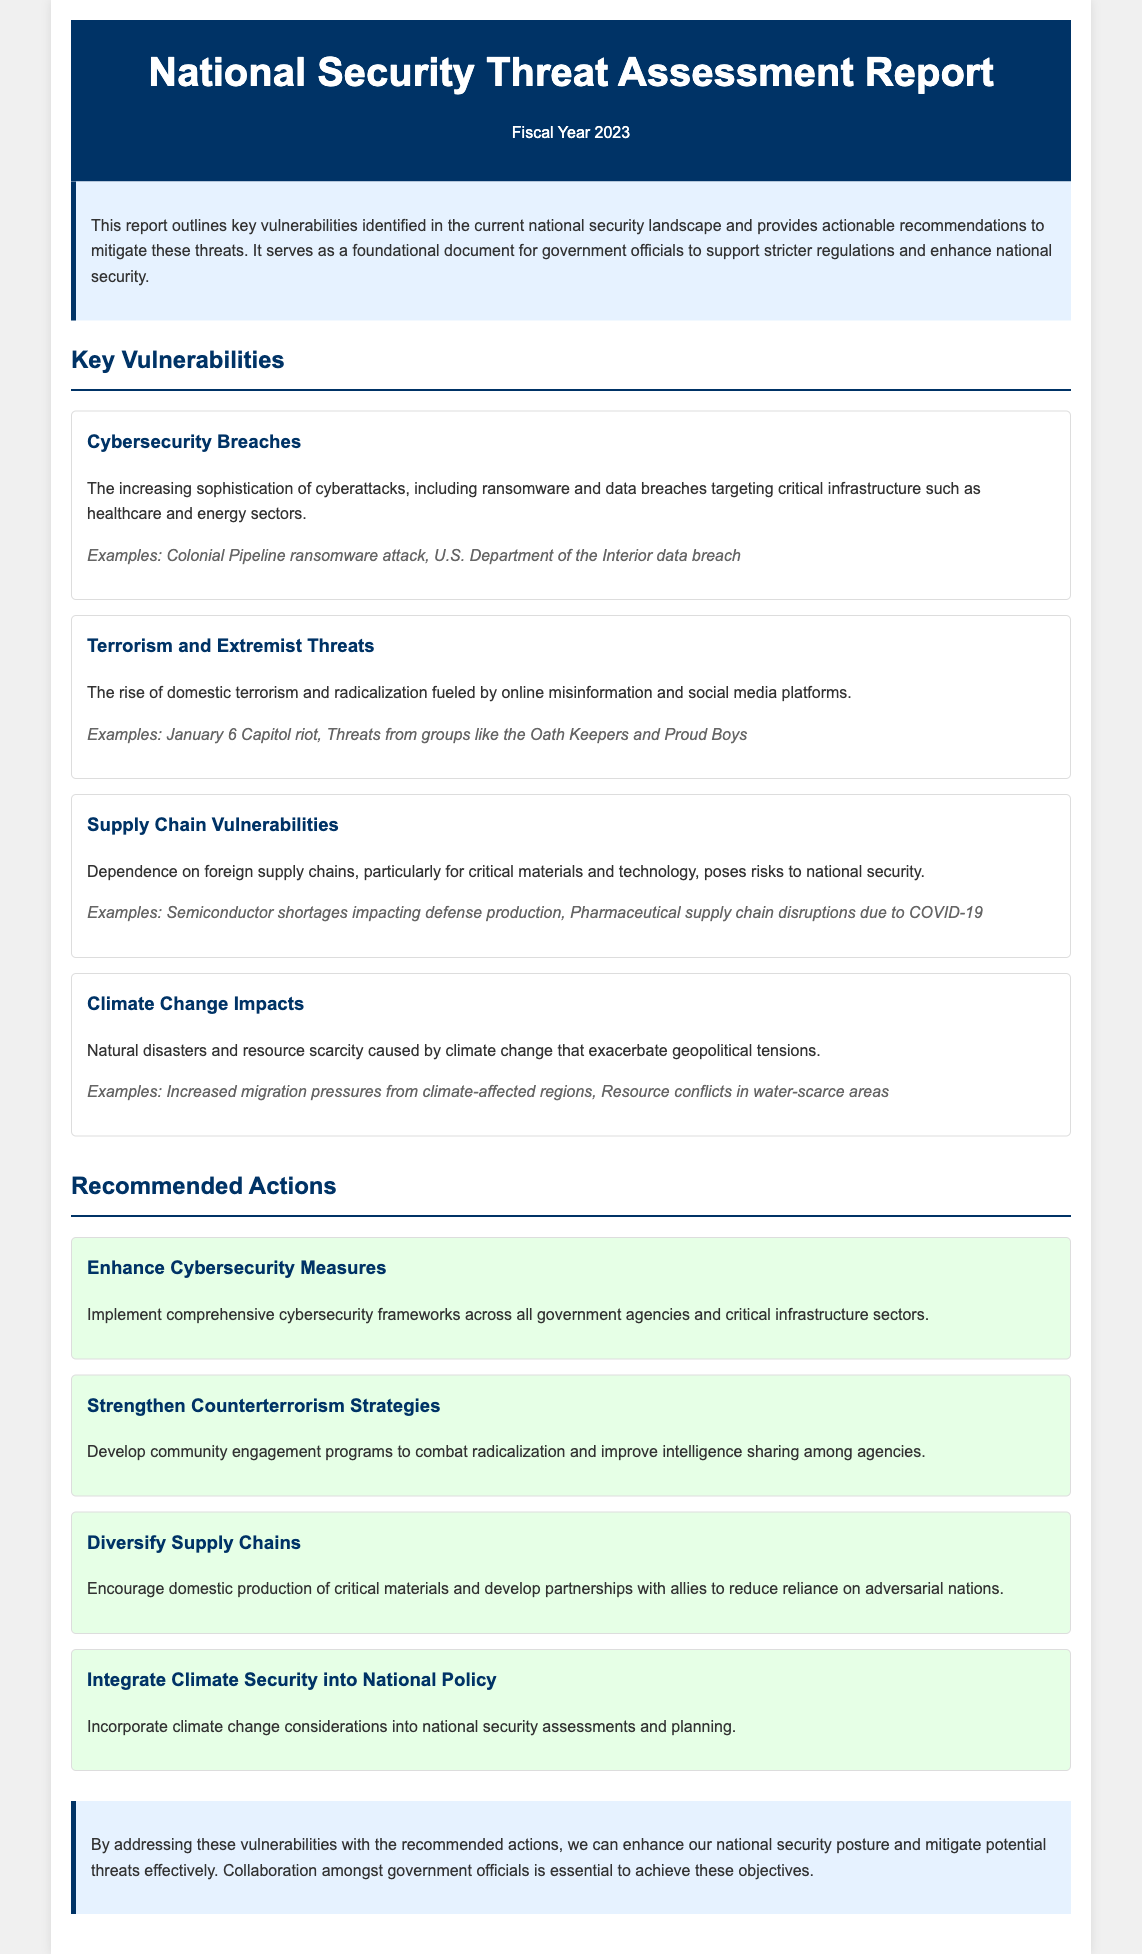What is the title of the report? The title of the report is found in the header section, summarizing its purpose and focus.
Answer: National Security Threat Assessment Report What fiscal year does the report cover? The report specifies the fiscal year in its title, indicating the period it addresses.
Answer: FY 2023 How many key vulnerabilities are identified in the report? The report lists four key vulnerabilities in the section discussing them.
Answer: Four Which vulnerability involves online misinformation? The report describes a specific threat related to misinformation and domestic issues.
Answer: Terrorism and Extremist Threats What is one example of a cybersecurity breach mentioned? The report provides examples related to cyberattacks in the cybersecurity vulnerability section.
Answer: Colonial Pipeline ransomware attack What action is recommended to enhance cybersecurity? The report suggests specific frameworks aimed at cybersecurity improvement in one of its action steps.
Answer: Enhance Cybersecurity Measures What does the report suggest to address supply chain vulnerabilities? The recommended action section provides an insight into managing supply chains for national security.
Answer: Diversify Supply Chains What critical factor is mentioned that can impact national security assessments? The report incorporates an important aspect relating to environmental changes affecting global stability.
Answer: Climate Change How should government agencies combat radicalization, according to the report? The recommended action provides a strategy to engage communities and improve intelligence sharing among agencies.
Answer: Strengthen Counterterrorism Strategies 